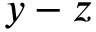<formula> <loc_0><loc_0><loc_500><loc_500>y - z</formula> 